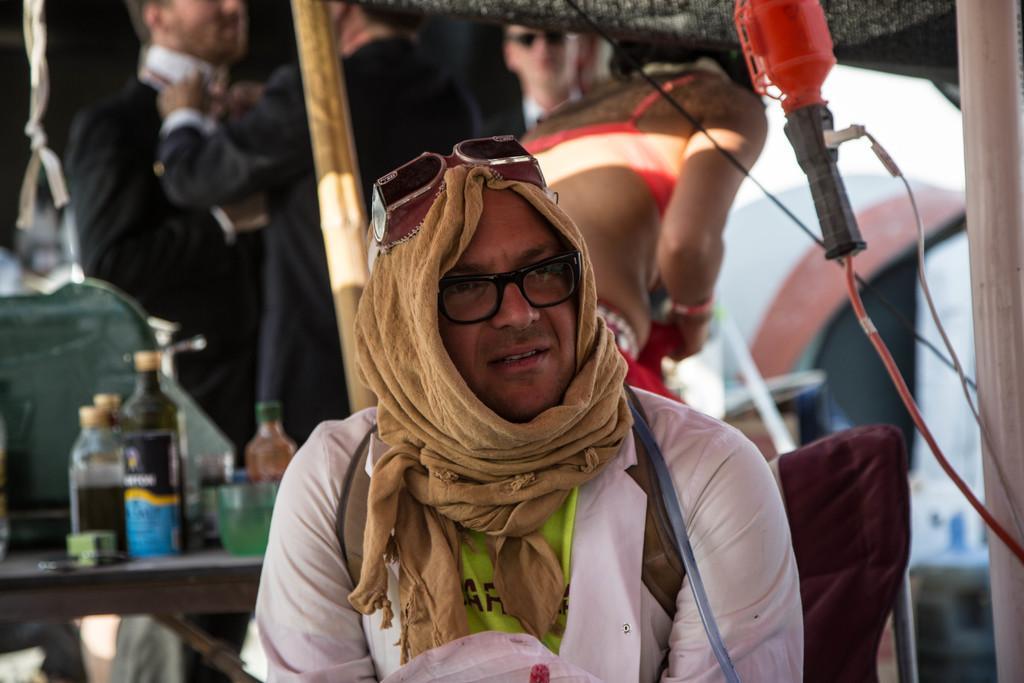Can you describe this image briefly? In this picture there is a person sitting. At the back there are bottles and there is a glass on the table. There are group of people standing. On the right side of the image there is a pipe. 